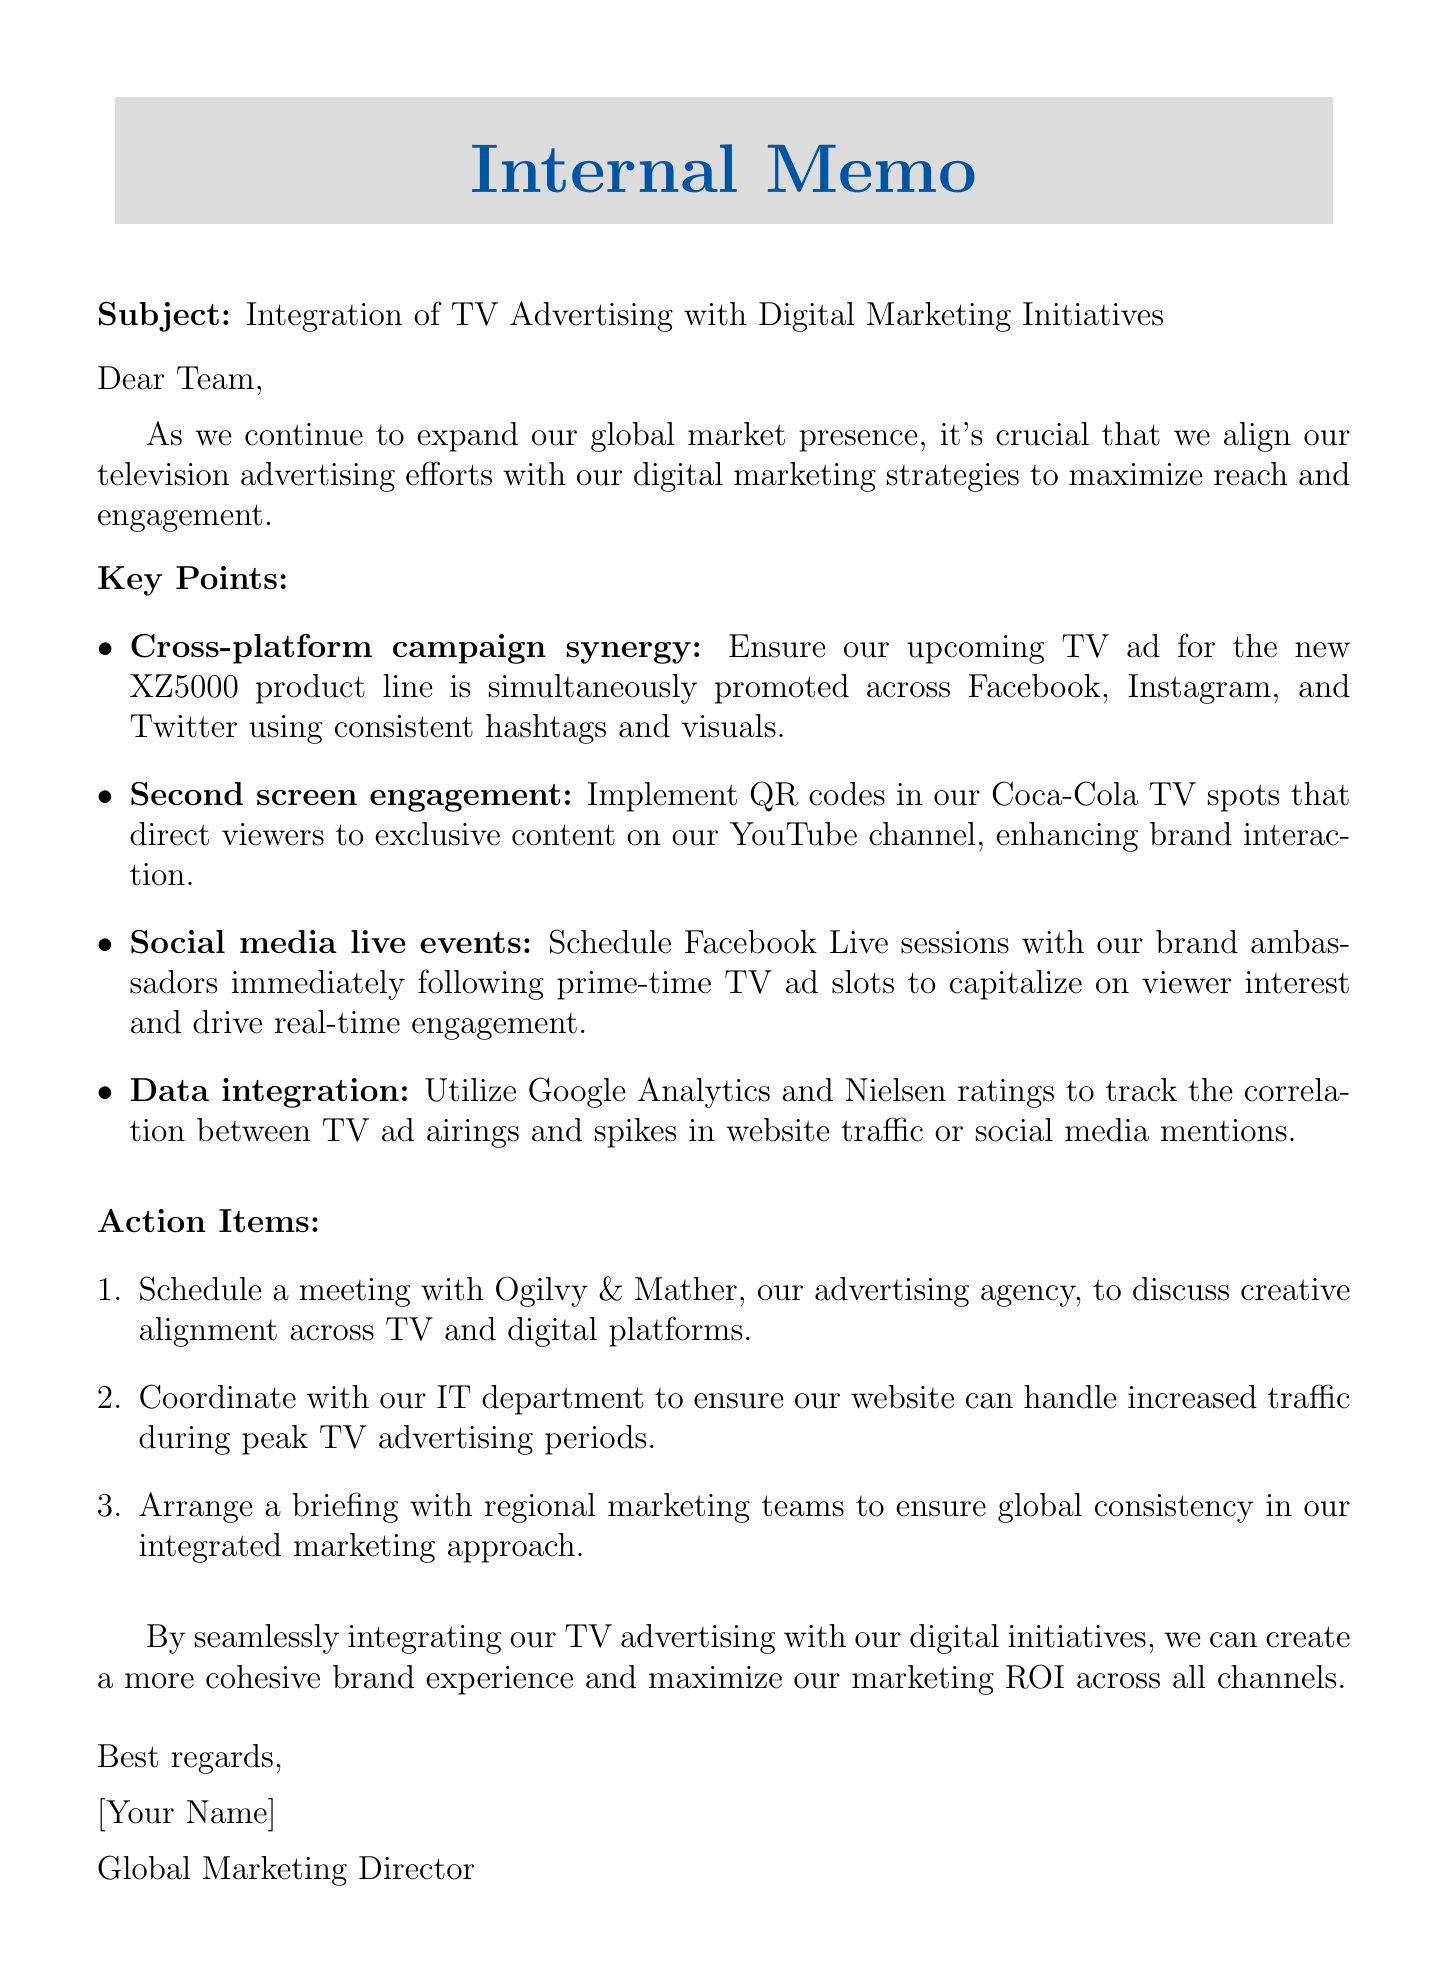What is the subject of the memo? The subject is stated at the beginning of the document to summarize its content.
Answer: Integration of TV Advertising with Digital Marketing Initiatives Who is the intended audience for the memo? The memo addresses the entire team, indicating it is meant for internal communication.
Answer: Team What is the first key point discussed in the memo? The first key point highlights a strategy related to cross-platform promotions.
Answer: Cross-platform campaign synergy What technology is suggested to track marketing effectiveness? The memo suggests using specific analytics tools to measure the impact of advertising.
Answer: Google Analytics and Nielsen ratings What is one action item mentioned in the memo? Action items are outlined to guide the next steps following the memo's key points.
Answer: Schedule a meeting with Ogilvy & Mather How many key points are listed in the memo? The number of key points is specified in a bullet list format within the document.
Answer: Four What will be implemented in Coca-Cola TV spots according to the memo? A specific feature mentioned in relation to enhancing viewer engagement is detailed in the memo.
Answer: QR codes What type of events are suggested to be scheduled after TV ads? The memo emphasizes using social media to engage viewers right after they watch the ads.
Answer: Facebook Live sessions What is the main goal of integrating TV advertising with digital initiatives? The memo concludes with the overall objective of the integration discussed throughout.
Answer: Maximize our marketing ROI across all channels 